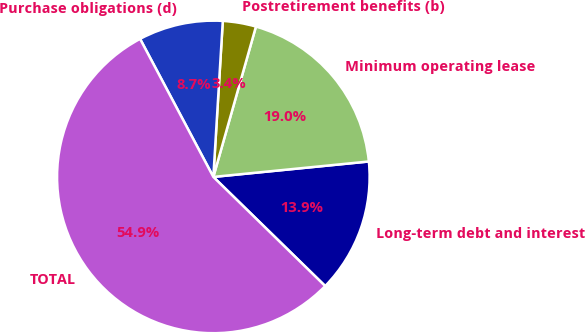Convert chart to OTSL. <chart><loc_0><loc_0><loc_500><loc_500><pie_chart><fcel>Long-term debt and interest<fcel>Minimum operating lease<fcel>Postretirement benefits (b)<fcel>Purchase obligations (d)<fcel>TOTAL<nl><fcel>13.88%<fcel>19.03%<fcel>3.43%<fcel>8.73%<fcel>54.93%<nl></chart> 